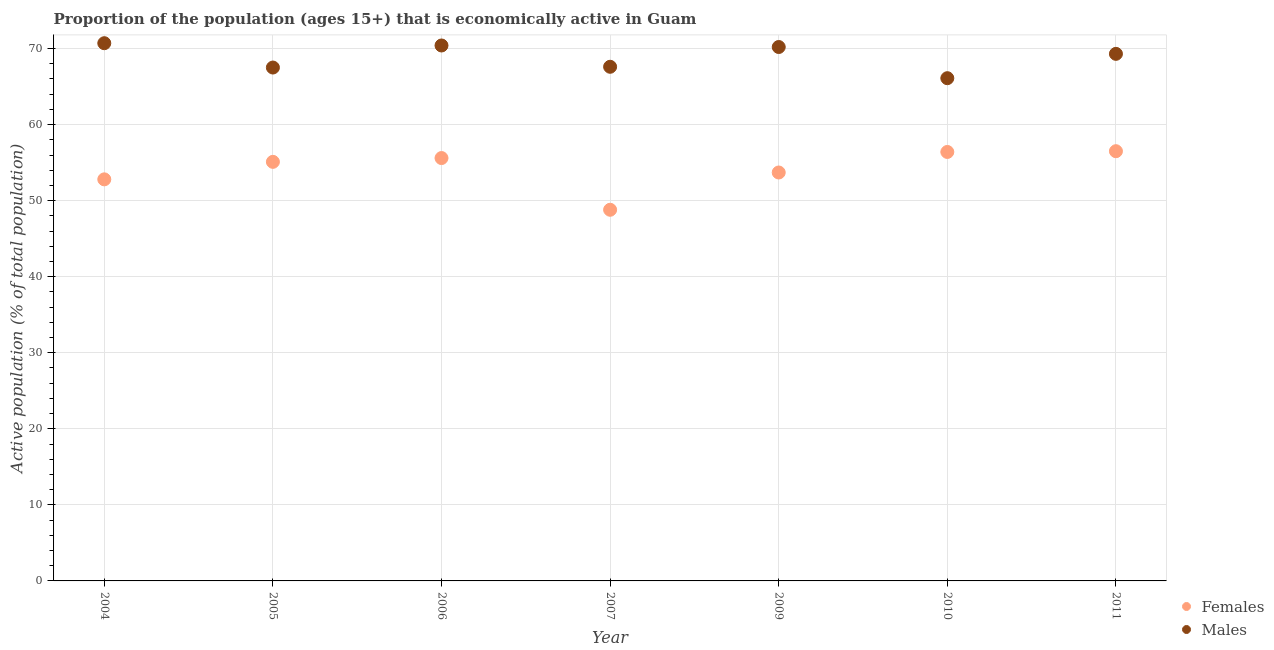Is the number of dotlines equal to the number of legend labels?
Provide a succinct answer. Yes. What is the percentage of economically active male population in 2010?
Provide a short and direct response. 66.1. Across all years, what is the maximum percentage of economically active female population?
Offer a very short reply. 56.5. Across all years, what is the minimum percentage of economically active female population?
Your answer should be very brief. 48.8. In which year was the percentage of economically active female population maximum?
Keep it short and to the point. 2011. In which year was the percentage of economically active female population minimum?
Make the answer very short. 2007. What is the total percentage of economically active male population in the graph?
Make the answer very short. 481.8. What is the difference between the percentage of economically active female population in 2009 and that in 2011?
Offer a very short reply. -2.8. What is the difference between the percentage of economically active male population in 2007 and the percentage of economically active female population in 2006?
Ensure brevity in your answer.  12. What is the average percentage of economically active male population per year?
Make the answer very short. 68.83. In the year 2007, what is the difference between the percentage of economically active female population and percentage of economically active male population?
Your answer should be compact. -18.8. In how many years, is the percentage of economically active male population greater than 22 %?
Your response must be concise. 7. What is the ratio of the percentage of economically active female population in 2005 to that in 2009?
Provide a succinct answer. 1.03. What is the difference between the highest and the second highest percentage of economically active male population?
Your answer should be very brief. 0.3. What is the difference between the highest and the lowest percentage of economically active male population?
Give a very brief answer. 4.6. Does the percentage of economically active female population monotonically increase over the years?
Ensure brevity in your answer.  No. Is the percentage of economically active male population strictly less than the percentage of economically active female population over the years?
Offer a terse response. No. How many dotlines are there?
Keep it short and to the point. 2. How many years are there in the graph?
Offer a terse response. 7. Are the values on the major ticks of Y-axis written in scientific E-notation?
Your answer should be compact. No. Where does the legend appear in the graph?
Your answer should be very brief. Bottom right. How are the legend labels stacked?
Offer a very short reply. Vertical. What is the title of the graph?
Your response must be concise. Proportion of the population (ages 15+) that is economically active in Guam. Does "Death rate" appear as one of the legend labels in the graph?
Provide a short and direct response. No. What is the label or title of the Y-axis?
Give a very brief answer. Active population (% of total population). What is the Active population (% of total population) in Females in 2004?
Ensure brevity in your answer.  52.8. What is the Active population (% of total population) of Males in 2004?
Your answer should be compact. 70.7. What is the Active population (% of total population) of Females in 2005?
Provide a succinct answer. 55.1. What is the Active population (% of total population) of Males in 2005?
Make the answer very short. 67.5. What is the Active population (% of total population) in Females in 2006?
Provide a short and direct response. 55.6. What is the Active population (% of total population) in Males in 2006?
Give a very brief answer. 70.4. What is the Active population (% of total population) of Females in 2007?
Offer a very short reply. 48.8. What is the Active population (% of total population) in Males in 2007?
Make the answer very short. 67.6. What is the Active population (% of total population) in Females in 2009?
Give a very brief answer. 53.7. What is the Active population (% of total population) in Males in 2009?
Keep it short and to the point. 70.2. What is the Active population (% of total population) in Females in 2010?
Offer a very short reply. 56.4. What is the Active population (% of total population) of Males in 2010?
Keep it short and to the point. 66.1. What is the Active population (% of total population) in Females in 2011?
Make the answer very short. 56.5. What is the Active population (% of total population) in Males in 2011?
Give a very brief answer. 69.3. Across all years, what is the maximum Active population (% of total population) of Females?
Provide a succinct answer. 56.5. Across all years, what is the maximum Active population (% of total population) of Males?
Make the answer very short. 70.7. Across all years, what is the minimum Active population (% of total population) of Females?
Your response must be concise. 48.8. Across all years, what is the minimum Active population (% of total population) of Males?
Offer a very short reply. 66.1. What is the total Active population (% of total population) of Females in the graph?
Your response must be concise. 378.9. What is the total Active population (% of total population) of Males in the graph?
Ensure brevity in your answer.  481.8. What is the difference between the Active population (% of total population) in Males in 2004 and that in 2005?
Provide a short and direct response. 3.2. What is the difference between the Active population (% of total population) of Females in 2004 and that in 2009?
Provide a short and direct response. -0.9. What is the difference between the Active population (% of total population) in Males in 2004 and that in 2009?
Provide a succinct answer. 0.5. What is the difference between the Active population (% of total population) in Females in 2004 and that in 2010?
Provide a short and direct response. -3.6. What is the difference between the Active population (% of total population) in Females in 2004 and that in 2011?
Ensure brevity in your answer.  -3.7. What is the difference between the Active population (% of total population) in Females in 2005 and that in 2006?
Ensure brevity in your answer.  -0.5. What is the difference between the Active population (% of total population) in Males in 2005 and that in 2006?
Offer a terse response. -2.9. What is the difference between the Active population (% of total population) in Males in 2005 and that in 2007?
Your answer should be compact. -0.1. What is the difference between the Active population (% of total population) in Females in 2005 and that in 2009?
Provide a short and direct response. 1.4. What is the difference between the Active population (% of total population) in Males in 2005 and that in 2009?
Offer a very short reply. -2.7. What is the difference between the Active population (% of total population) of Females in 2005 and that in 2010?
Make the answer very short. -1.3. What is the difference between the Active population (% of total population) in Females in 2006 and that in 2009?
Your answer should be compact. 1.9. What is the difference between the Active population (% of total population) in Males in 2006 and that in 2009?
Offer a very short reply. 0.2. What is the difference between the Active population (% of total population) of Females in 2006 and that in 2010?
Provide a short and direct response. -0.8. What is the difference between the Active population (% of total population) in Males in 2006 and that in 2011?
Provide a succinct answer. 1.1. What is the difference between the Active population (% of total population) in Females in 2007 and that in 2010?
Offer a terse response. -7.6. What is the difference between the Active population (% of total population) in Males in 2007 and that in 2010?
Offer a terse response. 1.5. What is the difference between the Active population (% of total population) of Females in 2009 and that in 2010?
Ensure brevity in your answer.  -2.7. What is the difference between the Active population (% of total population) in Females in 2009 and that in 2011?
Give a very brief answer. -2.8. What is the difference between the Active population (% of total population) in Females in 2004 and the Active population (% of total population) in Males in 2005?
Your answer should be very brief. -14.7. What is the difference between the Active population (% of total population) of Females in 2004 and the Active population (% of total population) of Males in 2006?
Your answer should be compact. -17.6. What is the difference between the Active population (% of total population) in Females in 2004 and the Active population (% of total population) in Males in 2007?
Provide a short and direct response. -14.8. What is the difference between the Active population (% of total population) of Females in 2004 and the Active population (% of total population) of Males in 2009?
Give a very brief answer. -17.4. What is the difference between the Active population (% of total population) in Females in 2004 and the Active population (% of total population) in Males in 2010?
Your response must be concise. -13.3. What is the difference between the Active population (% of total population) in Females in 2004 and the Active population (% of total population) in Males in 2011?
Provide a succinct answer. -16.5. What is the difference between the Active population (% of total population) in Females in 2005 and the Active population (% of total population) in Males in 2006?
Your response must be concise. -15.3. What is the difference between the Active population (% of total population) of Females in 2005 and the Active population (% of total population) of Males in 2007?
Provide a short and direct response. -12.5. What is the difference between the Active population (% of total population) of Females in 2005 and the Active population (% of total population) of Males in 2009?
Give a very brief answer. -15.1. What is the difference between the Active population (% of total population) in Females in 2005 and the Active population (% of total population) in Males in 2011?
Ensure brevity in your answer.  -14.2. What is the difference between the Active population (% of total population) of Females in 2006 and the Active population (% of total population) of Males in 2007?
Make the answer very short. -12. What is the difference between the Active population (% of total population) of Females in 2006 and the Active population (% of total population) of Males in 2009?
Your answer should be very brief. -14.6. What is the difference between the Active population (% of total population) of Females in 2006 and the Active population (% of total population) of Males in 2011?
Your answer should be very brief. -13.7. What is the difference between the Active population (% of total population) of Females in 2007 and the Active population (% of total population) of Males in 2009?
Your answer should be very brief. -21.4. What is the difference between the Active population (% of total population) of Females in 2007 and the Active population (% of total population) of Males in 2010?
Provide a succinct answer. -17.3. What is the difference between the Active population (% of total population) in Females in 2007 and the Active population (% of total population) in Males in 2011?
Your answer should be very brief. -20.5. What is the difference between the Active population (% of total population) in Females in 2009 and the Active population (% of total population) in Males in 2010?
Your answer should be very brief. -12.4. What is the difference between the Active population (% of total population) of Females in 2009 and the Active population (% of total population) of Males in 2011?
Your answer should be very brief. -15.6. What is the difference between the Active population (% of total population) in Females in 2010 and the Active population (% of total population) in Males in 2011?
Provide a succinct answer. -12.9. What is the average Active population (% of total population) in Females per year?
Offer a very short reply. 54.13. What is the average Active population (% of total population) in Males per year?
Provide a short and direct response. 68.83. In the year 2004, what is the difference between the Active population (% of total population) in Females and Active population (% of total population) in Males?
Keep it short and to the point. -17.9. In the year 2005, what is the difference between the Active population (% of total population) of Females and Active population (% of total population) of Males?
Ensure brevity in your answer.  -12.4. In the year 2006, what is the difference between the Active population (% of total population) of Females and Active population (% of total population) of Males?
Your answer should be very brief. -14.8. In the year 2007, what is the difference between the Active population (% of total population) in Females and Active population (% of total population) in Males?
Provide a short and direct response. -18.8. In the year 2009, what is the difference between the Active population (% of total population) of Females and Active population (% of total population) of Males?
Offer a very short reply. -16.5. In the year 2011, what is the difference between the Active population (% of total population) of Females and Active population (% of total population) of Males?
Offer a very short reply. -12.8. What is the ratio of the Active population (% of total population) of Males in 2004 to that in 2005?
Provide a succinct answer. 1.05. What is the ratio of the Active population (% of total population) in Females in 2004 to that in 2006?
Your answer should be very brief. 0.95. What is the ratio of the Active population (% of total population) of Males in 2004 to that in 2006?
Offer a terse response. 1. What is the ratio of the Active population (% of total population) of Females in 2004 to that in 2007?
Offer a terse response. 1.08. What is the ratio of the Active population (% of total population) of Males in 2004 to that in 2007?
Your response must be concise. 1.05. What is the ratio of the Active population (% of total population) in Females in 2004 to that in 2009?
Your answer should be very brief. 0.98. What is the ratio of the Active population (% of total population) of Males in 2004 to that in 2009?
Your answer should be very brief. 1.01. What is the ratio of the Active population (% of total population) in Females in 2004 to that in 2010?
Your answer should be very brief. 0.94. What is the ratio of the Active population (% of total population) of Males in 2004 to that in 2010?
Your response must be concise. 1.07. What is the ratio of the Active population (% of total population) of Females in 2004 to that in 2011?
Provide a short and direct response. 0.93. What is the ratio of the Active population (% of total population) in Males in 2004 to that in 2011?
Provide a short and direct response. 1.02. What is the ratio of the Active population (% of total population) of Males in 2005 to that in 2006?
Keep it short and to the point. 0.96. What is the ratio of the Active population (% of total population) of Females in 2005 to that in 2007?
Keep it short and to the point. 1.13. What is the ratio of the Active population (% of total population) in Males in 2005 to that in 2007?
Give a very brief answer. 1. What is the ratio of the Active population (% of total population) of Females in 2005 to that in 2009?
Your answer should be very brief. 1.03. What is the ratio of the Active population (% of total population) of Males in 2005 to that in 2009?
Make the answer very short. 0.96. What is the ratio of the Active population (% of total population) of Males in 2005 to that in 2010?
Keep it short and to the point. 1.02. What is the ratio of the Active population (% of total population) in Females in 2005 to that in 2011?
Offer a very short reply. 0.98. What is the ratio of the Active population (% of total population) of Males in 2005 to that in 2011?
Provide a succinct answer. 0.97. What is the ratio of the Active population (% of total population) of Females in 2006 to that in 2007?
Make the answer very short. 1.14. What is the ratio of the Active population (% of total population) of Males in 2006 to that in 2007?
Your response must be concise. 1.04. What is the ratio of the Active population (% of total population) in Females in 2006 to that in 2009?
Offer a terse response. 1.04. What is the ratio of the Active population (% of total population) of Males in 2006 to that in 2009?
Offer a very short reply. 1. What is the ratio of the Active population (% of total population) of Females in 2006 to that in 2010?
Offer a terse response. 0.99. What is the ratio of the Active population (% of total population) of Males in 2006 to that in 2010?
Offer a very short reply. 1.07. What is the ratio of the Active population (% of total population) of Females in 2006 to that in 2011?
Ensure brevity in your answer.  0.98. What is the ratio of the Active population (% of total population) of Males in 2006 to that in 2011?
Provide a short and direct response. 1.02. What is the ratio of the Active population (% of total population) of Females in 2007 to that in 2009?
Offer a very short reply. 0.91. What is the ratio of the Active population (% of total population) in Males in 2007 to that in 2009?
Offer a very short reply. 0.96. What is the ratio of the Active population (% of total population) in Females in 2007 to that in 2010?
Your answer should be very brief. 0.87. What is the ratio of the Active population (% of total population) in Males in 2007 to that in 2010?
Offer a very short reply. 1.02. What is the ratio of the Active population (% of total population) in Females in 2007 to that in 2011?
Provide a short and direct response. 0.86. What is the ratio of the Active population (% of total population) in Males in 2007 to that in 2011?
Provide a succinct answer. 0.98. What is the ratio of the Active population (% of total population) in Females in 2009 to that in 2010?
Provide a short and direct response. 0.95. What is the ratio of the Active population (% of total population) in Males in 2009 to that in 2010?
Your answer should be compact. 1.06. What is the ratio of the Active population (% of total population) of Females in 2009 to that in 2011?
Offer a very short reply. 0.95. What is the ratio of the Active population (% of total population) in Males in 2010 to that in 2011?
Your response must be concise. 0.95. What is the difference between the highest and the lowest Active population (% of total population) of Females?
Make the answer very short. 7.7. 